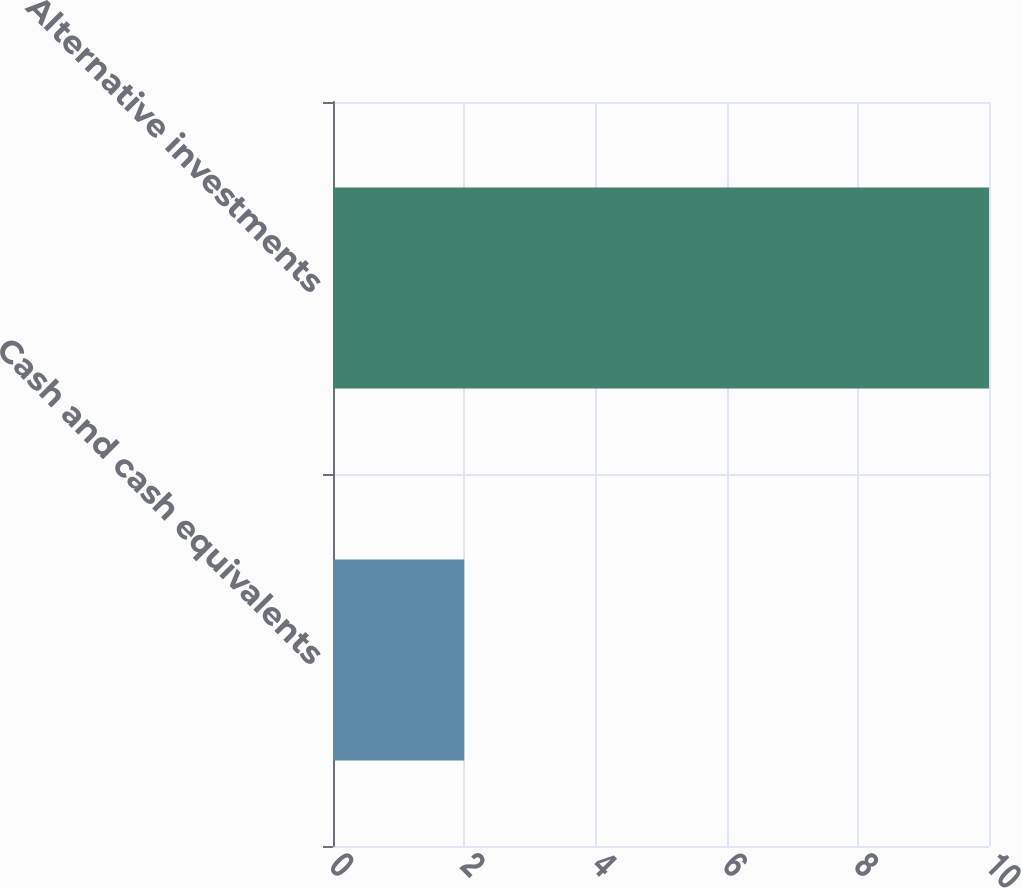Convert chart to OTSL. <chart><loc_0><loc_0><loc_500><loc_500><bar_chart><fcel>Cash and cash equivalents<fcel>Alternative investments<nl><fcel>2<fcel>10<nl></chart> 